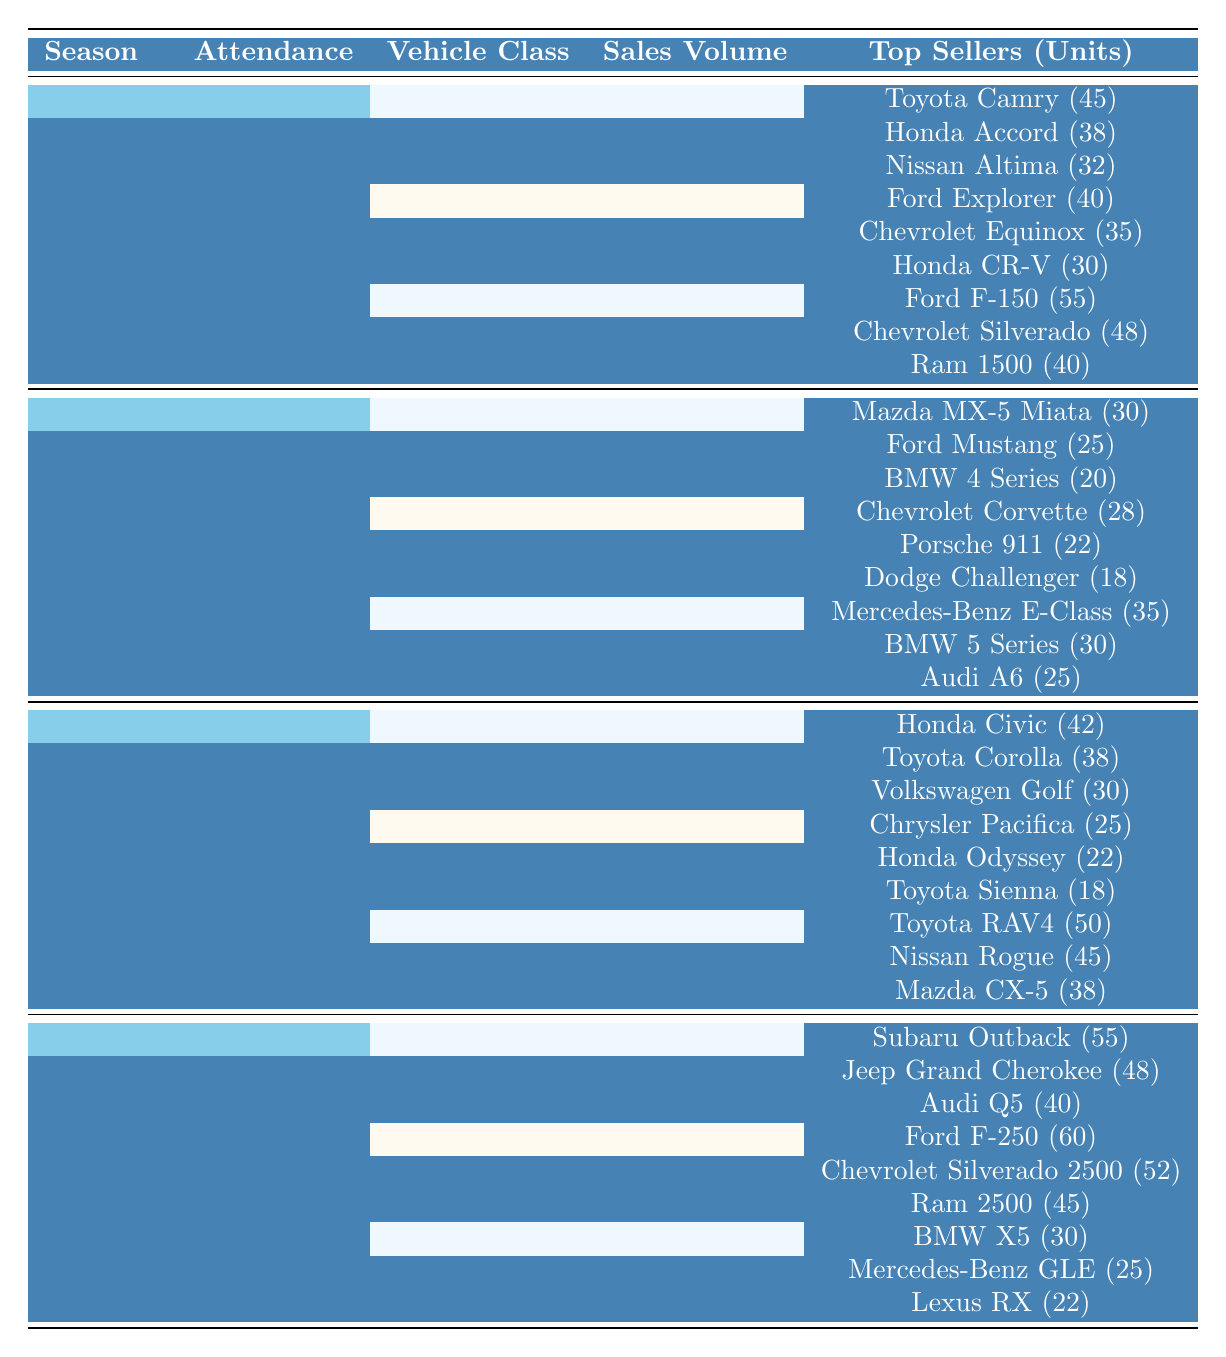What is the total sales volume for SUVs in Spring? The table shows that the sales volume for SUVs in Spring is 280.
Answer: 280 Which season had the highest attendance at the auction? By comparing the attendance figures, Summer had the highest attendance at 1450.
Answer: Summer Are there more units sold of the Ford F-150 than the Ford Explorer in Spring? The Ford F-150 sold 55 units while the Ford Explorer sold 40 units, so yes, the Ford F-150 had more units sold.
Answer: Yes What is the difference in attendance between Winter and Fall? Winter had an attendance of 950, and Fall had an attendance of 1100. The difference is 1100 - 950 = 150.
Answer: 150 Which vehicle class had the highest sales volume in Summer? In Summer, Luxury Sedans had the highest sales volume at 220, compared to Convertibles (180) and Sports Cars (150).
Answer: Luxury Sedans What is the total number of units sold for the top three sellers of Compact Cars in Fall? The top three sellers are Honda Civic (42), Toyota Corolla (38), and Volkswagen Golf (30). Their total units sold is 42 + 38 + 30 = 110.
Answer: 110 Is it true that the Audi Q5 sold more units than the Lexus RX in Winter? The Audi Q5 sold 40 units, and the Lexus RX sold 22 units. Therefore, Audi Q5 sold more units than Lexus RX.
Answer: Yes Which vehicle class had the least sales volume in Summer? The table shows that Sports Cars had the least sales volume in Summer at 150, compared to Convertibles (180) and Luxury Sedans (220).
Answer: Sports Cars How many total units were sold for AWD Vehicles and Pickup Trucks combined in Winter? The AWD Vehicles sold 310 units, and Pickup Trucks sold 280 units. So, the total is 310 + 280 = 590.
Answer: 590 Which top seller had the lowest units sold in Spring? The Nissan Altima had the lowest units sold among the top sellers in Spring with 32 units.
Answer: Nissan Altima 